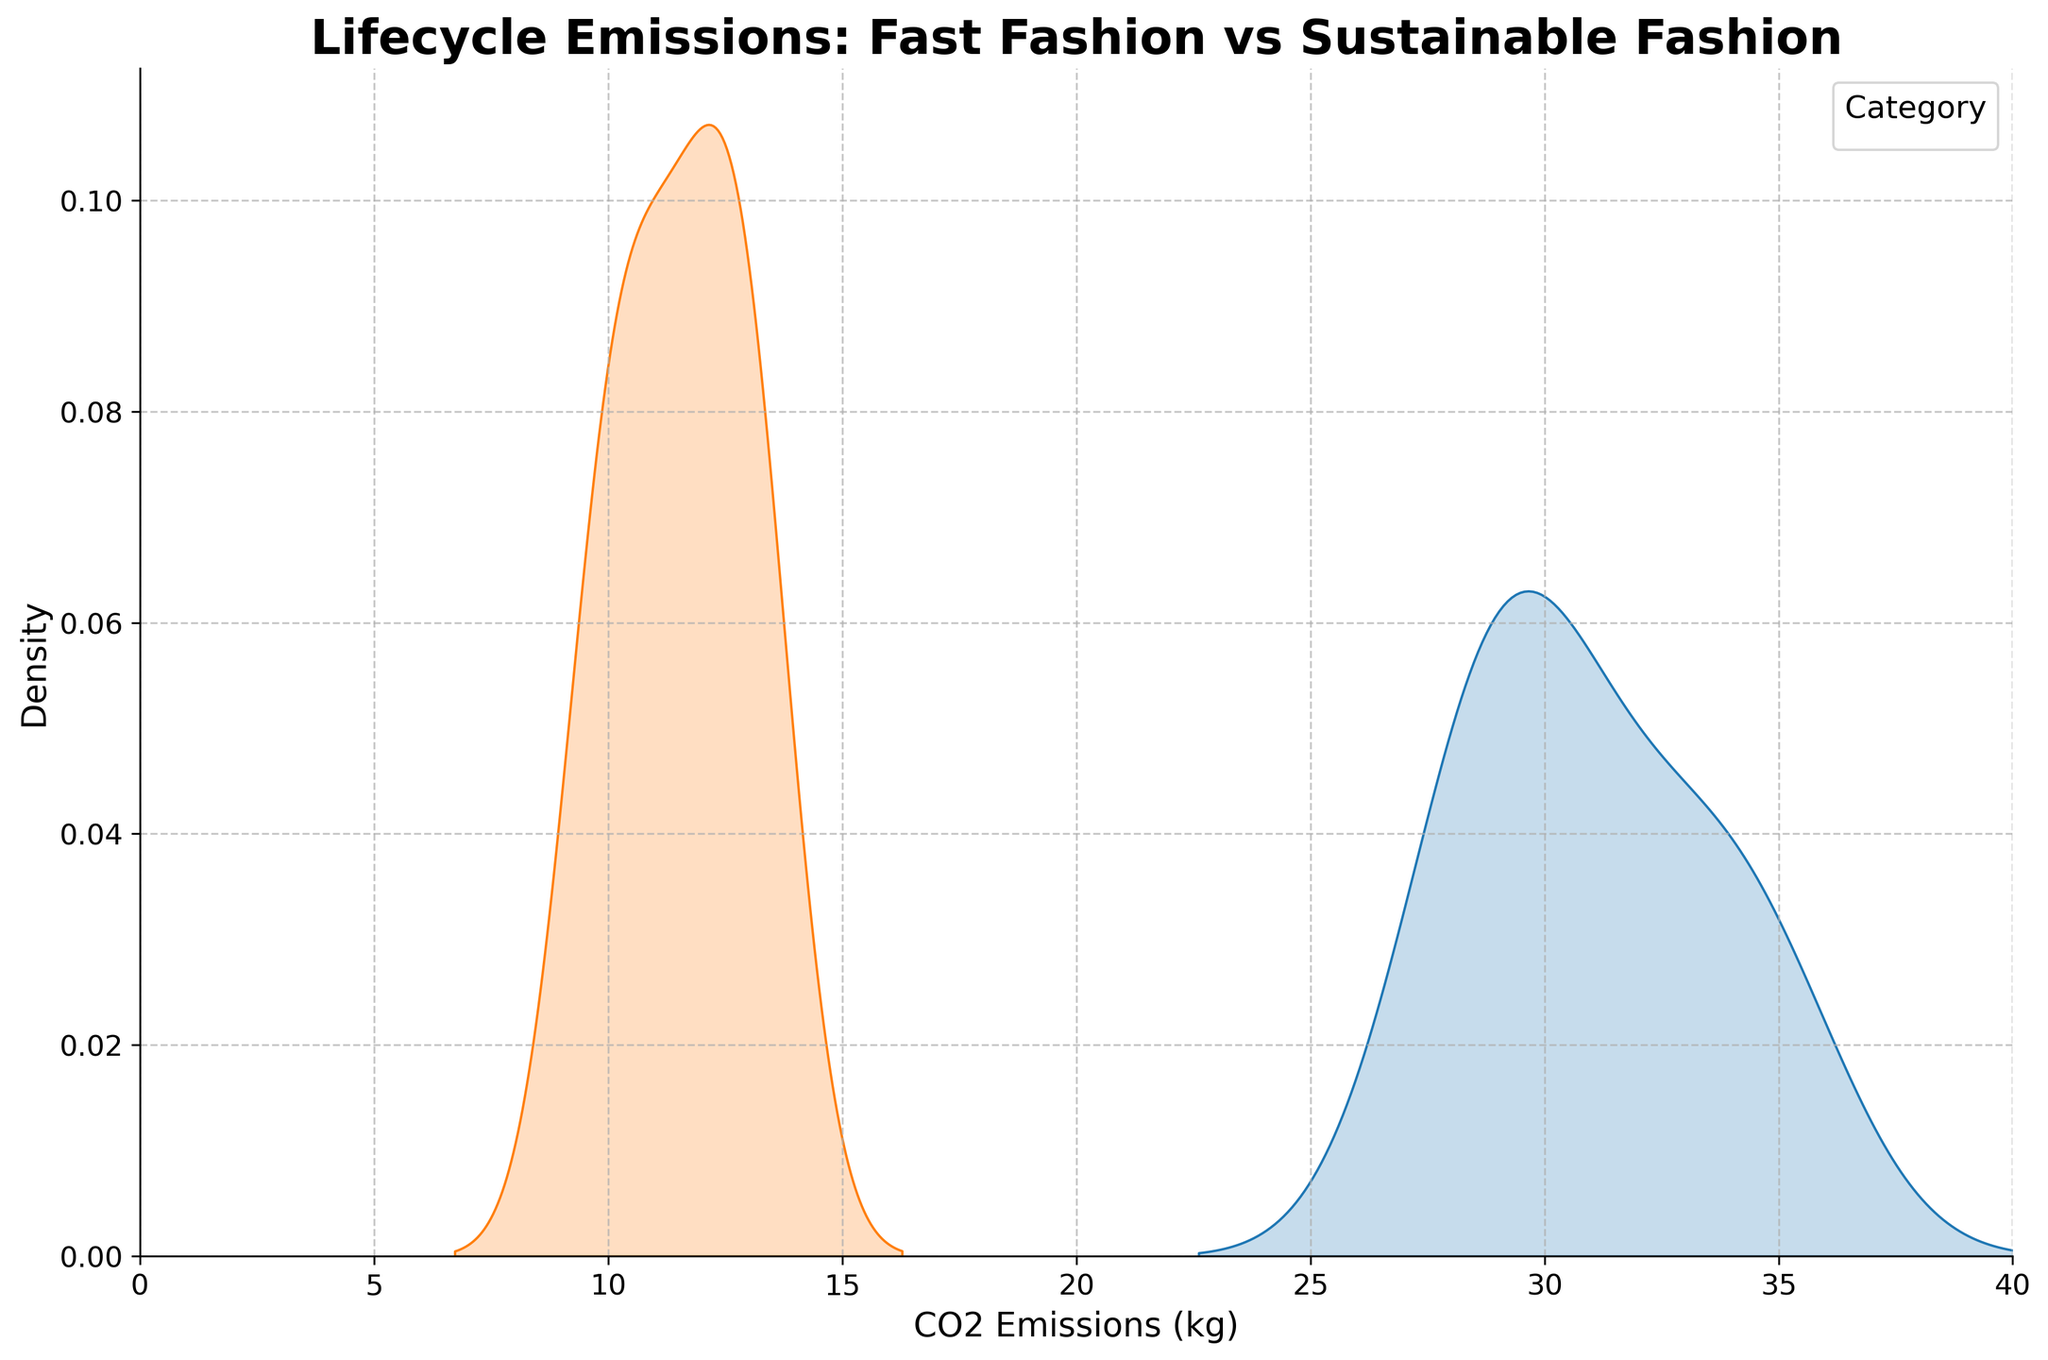What is the title of the figure? The title is usually displayed at the top of the figure. It summarizes the main topic of the plot.
Answer: Lifecycle Emissions: Fast Fashion vs Sustainable Fashion What does the x-axis represent? The x-axis usually represents a variable in the data. Here, it shows the measurement unit of the variable compared across the categories.
Answer: CO2 Emissions (kg) What are the two categories compared in the figure? These categories are normally labeled in the legend of the plot, which helps identify the different groups.
Answer: Fast Fashion and Sustainable Fashion Which category shows a lower peak in the density plot? The density plot shows peaks that indicate where data points are most concentrated. The category with the lower peak indicates a smaller concentration of data at that specific emission range.
Answer: Sustainable Fashion At approximately what CO2 emission value do both categories start to show density presence? This is where both density curves start rising above zero. Look for the point on the x-axis where the curves of both categories start.
Answer: Around 9 kg Which category has the highest individual data point for CO2 emissions, and what is the approximate value? Look for the farthest extent of the density plot on the x-axis for each category. The category with the plot extending furthest to the right has the highest data point.
Answer: Fast Fashion, approximately 35 kg How does the CO2 emission range differ between fast fashion and sustainable fashion? Compare the spread or range of each category's density curve along the x-axis. This shows how the CO2 emissions distribution varies between categories.
Answer: Fast fashion ranges from around 28 kg to 35 kg, while sustainable fashion ranges from about 9 kg to 14 kg Approximately, what is the median CO2 emission in the sustainable fashion category? The median is the middle point of the data. In a density plot, it can be estimated by finding the middle of the area under the curve for the category.
Answer: Approximately 11-12 kg How do the widths of the density curves compare between fast fashion and sustainable fashion? The width of the density curves indicates the spread of the data. A wider curve suggests more variability, while a narrower curve suggests less.
Answer: Fast Fashion has a narrower spread compared to Sustainable Fashion What can be inferred about the environmental impact of fast fashion versus sustainable fashion from this plot? Infer from the overall shape and spread of the density curves, and consider what higher or lower CO2 emissions imply about environmental impact.
Answer: Fast Fashion generally has higher CO2 emissions, indicating a greater environmental impact 